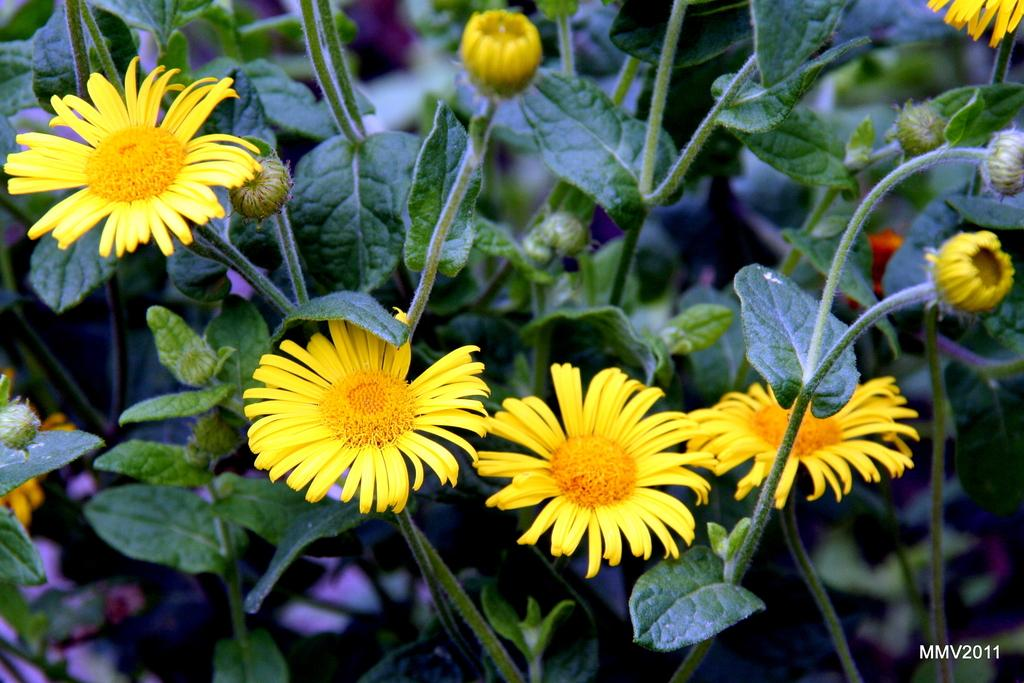What type of flowers are in the image? There are sunflowers in the image. What color are the sunflowers? The sunflowers are yellow. What else can be seen in the image besides the sunflowers? There are plants in the image. What stage of growth are the flowers in the background? There are flower buds in the background of the image. What type of error can be seen in the image? There is no error present in the image; it is a photograph of sunflowers and plants. Who is the creator of the sunflowers in the image? The sunflowers are a natural creation and not created by a specific person. 